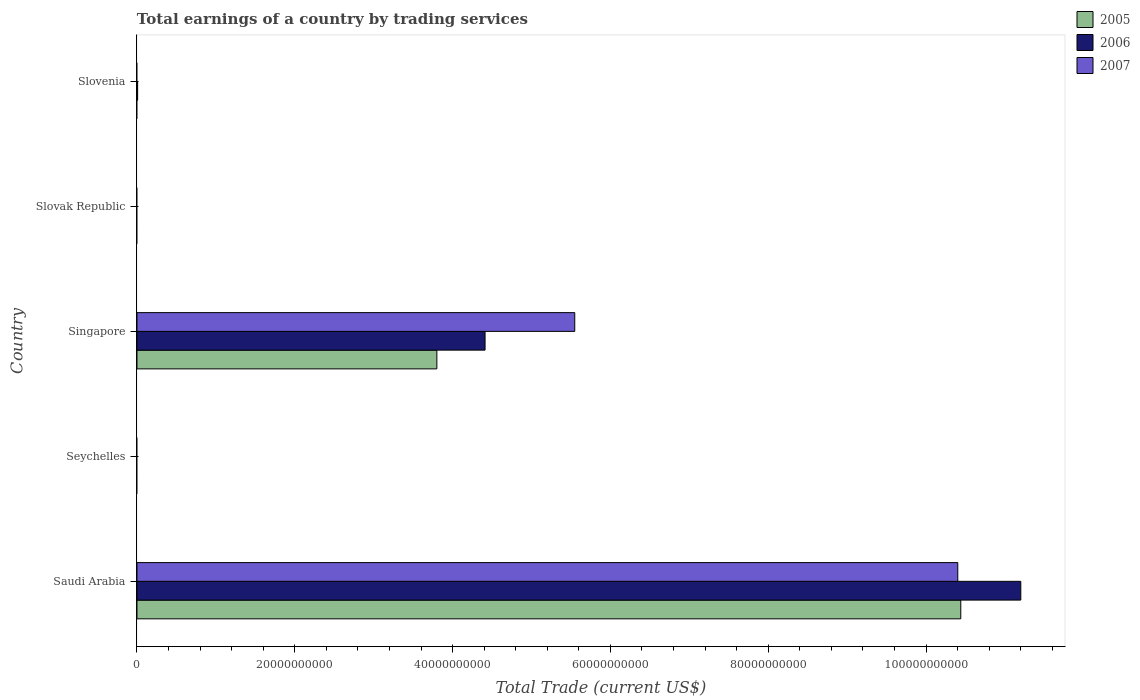How many different coloured bars are there?
Offer a very short reply. 3. Are the number of bars per tick equal to the number of legend labels?
Give a very brief answer. No. Are the number of bars on each tick of the Y-axis equal?
Offer a very short reply. No. How many bars are there on the 3rd tick from the top?
Offer a terse response. 3. What is the label of the 5th group of bars from the top?
Provide a short and direct response. Saudi Arabia. What is the total earnings in 2006 in Saudi Arabia?
Provide a succinct answer. 1.12e+11. Across all countries, what is the maximum total earnings in 2005?
Make the answer very short. 1.04e+11. In which country was the total earnings in 2007 maximum?
Your answer should be compact. Saudi Arabia. What is the total total earnings in 2005 in the graph?
Give a very brief answer. 1.42e+11. What is the difference between the total earnings in 2007 in Slovak Republic and the total earnings in 2006 in Slovenia?
Provide a short and direct response. -8.38e+07. What is the average total earnings in 2007 per country?
Make the answer very short. 3.19e+1. What is the difference between the total earnings in 2006 and total earnings in 2007 in Singapore?
Offer a terse response. -1.14e+1. Is the total earnings in 2005 in Saudi Arabia less than that in Singapore?
Make the answer very short. No. What is the difference between the highest and the second highest total earnings in 2006?
Give a very brief answer. 6.79e+1. What is the difference between the highest and the lowest total earnings in 2005?
Make the answer very short. 1.04e+11. How many bars are there?
Keep it short and to the point. 7. Are all the bars in the graph horizontal?
Provide a short and direct response. Yes. What is the difference between two consecutive major ticks on the X-axis?
Give a very brief answer. 2.00e+1. Does the graph contain grids?
Keep it short and to the point. No. How many legend labels are there?
Your response must be concise. 3. How are the legend labels stacked?
Give a very brief answer. Vertical. What is the title of the graph?
Make the answer very short. Total earnings of a country by trading services. Does "1995" appear as one of the legend labels in the graph?
Provide a succinct answer. No. What is the label or title of the X-axis?
Ensure brevity in your answer.  Total Trade (current US$). What is the Total Trade (current US$) of 2005 in Saudi Arabia?
Offer a terse response. 1.04e+11. What is the Total Trade (current US$) of 2006 in Saudi Arabia?
Ensure brevity in your answer.  1.12e+11. What is the Total Trade (current US$) in 2007 in Saudi Arabia?
Your answer should be very brief. 1.04e+11. What is the Total Trade (current US$) of 2006 in Seychelles?
Provide a succinct answer. 0. What is the Total Trade (current US$) of 2007 in Seychelles?
Offer a very short reply. 0. What is the Total Trade (current US$) in 2005 in Singapore?
Your answer should be very brief. 3.80e+1. What is the Total Trade (current US$) of 2006 in Singapore?
Give a very brief answer. 4.41e+1. What is the Total Trade (current US$) in 2007 in Singapore?
Make the answer very short. 5.55e+1. What is the Total Trade (current US$) in 2006 in Slovenia?
Keep it short and to the point. 8.38e+07. What is the Total Trade (current US$) in 2007 in Slovenia?
Ensure brevity in your answer.  0. Across all countries, what is the maximum Total Trade (current US$) in 2005?
Your answer should be very brief. 1.04e+11. Across all countries, what is the maximum Total Trade (current US$) of 2006?
Your response must be concise. 1.12e+11. Across all countries, what is the maximum Total Trade (current US$) in 2007?
Your answer should be compact. 1.04e+11. Across all countries, what is the minimum Total Trade (current US$) in 2005?
Your answer should be very brief. 0. Across all countries, what is the minimum Total Trade (current US$) of 2006?
Offer a very short reply. 0. What is the total Total Trade (current US$) in 2005 in the graph?
Your answer should be compact. 1.42e+11. What is the total Total Trade (current US$) of 2006 in the graph?
Make the answer very short. 1.56e+11. What is the total Total Trade (current US$) in 2007 in the graph?
Provide a succinct answer. 1.60e+11. What is the difference between the Total Trade (current US$) in 2005 in Saudi Arabia and that in Singapore?
Keep it short and to the point. 6.64e+1. What is the difference between the Total Trade (current US$) in 2006 in Saudi Arabia and that in Singapore?
Provide a succinct answer. 6.79e+1. What is the difference between the Total Trade (current US$) in 2007 in Saudi Arabia and that in Singapore?
Your answer should be compact. 4.85e+1. What is the difference between the Total Trade (current US$) of 2006 in Saudi Arabia and that in Slovenia?
Provide a short and direct response. 1.12e+11. What is the difference between the Total Trade (current US$) of 2006 in Singapore and that in Slovenia?
Ensure brevity in your answer.  4.40e+1. What is the difference between the Total Trade (current US$) in 2005 in Saudi Arabia and the Total Trade (current US$) in 2006 in Singapore?
Your response must be concise. 6.03e+1. What is the difference between the Total Trade (current US$) in 2005 in Saudi Arabia and the Total Trade (current US$) in 2007 in Singapore?
Keep it short and to the point. 4.89e+1. What is the difference between the Total Trade (current US$) of 2006 in Saudi Arabia and the Total Trade (current US$) of 2007 in Singapore?
Your answer should be compact. 5.65e+1. What is the difference between the Total Trade (current US$) of 2005 in Saudi Arabia and the Total Trade (current US$) of 2006 in Slovenia?
Offer a very short reply. 1.04e+11. What is the difference between the Total Trade (current US$) of 2005 in Singapore and the Total Trade (current US$) of 2006 in Slovenia?
Make the answer very short. 3.79e+1. What is the average Total Trade (current US$) in 2005 per country?
Offer a terse response. 2.85e+1. What is the average Total Trade (current US$) in 2006 per country?
Make the answer very short. 3.12e+1. What is the average Total Trade (current US$) of 2007 per country?
Ensure brevity in your answer.  3.19e+1. What is the difference between the Total Trade (current US$) of 2005 and Total Trade (current US$) of 2006 in Saudi Arabia?
Make the answer very short. -7.61e+09. What is the difference between the Total Trade (current US$) in 2005 and Total Trade (current US$) in 2007 in Saudi Arabia?
Keep it short and to the point. 3.80e+08. What is the difference between the Total Trade (current US$) of 2006 and Total Trade (current US$) of 2007 in Saudi Arabia?
Your response must be concise. 7.99e+09. What is the difference between the Total Trade (current US$) in 2005 and Total Trade (current US$) in 2006 in Singapore?
Offer a terse response. -6.11e+09. What is the difference between the Total Trade (current US$) in 2005 and Total Trade (current US$) in 2007 in Singapore?
Provide a short and direct response. -1.75e+1. What is the difference between the Total Trade (current US$) of 2006 and Total Trade (current US$) of 2007 in Singapore?
Offer a terse response. -1.14e+1. What is the ratio of the Total Trade (current US$) of 2005 in Saudi Arabia to that in Singapore?
Your response must be concise. 2.75. What is the ratio of the Total Trade (current US$) of 2006 in Saudi Arabia to that in Singapore?
Provide a short and direct response. 2.54. What is the ratio of the Total Trade (current US$) of 2007 in Saudi Arabia to that in Singapore?
Offer a very short reply. 1.87. What is the ratio of the Total Trade (current US$) of 2006 in Saudi Arabia to that in Slovenia?
Offer a terse response. 1336.89. What is the ratio of the Total Trade (current US$) of 2006 in Singapore to that in Slovenia?
Ensure brevity in your answer.  526.53. What is the difference between the highest and the second highest Total Trade (current US$) of 2006?
Keep it short and to the point. 6.79e+1. What is the difference between the highest and the lowest Total Trade (current US$) of 2005?
Your answer should be very brief. 1.04e+11. What is the difference between the highest and the lowest Total Trade (current US$) in 2006?
Ensure brevity in your answer.  1.12e+11. What is the difference between the highest and the lowest Total Trade (current US$) of 2007?
Your response must be concise. 1.04e+11. 